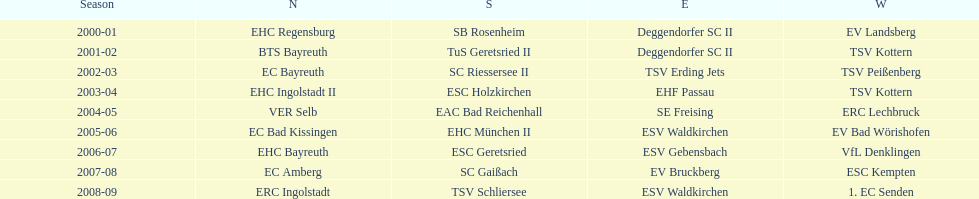Which teams have won in the bavarian ice hockey leagues between 2000 and 2009? EHC Regensburg, SB Rosenheim, Deggendorfer SC II, EV Landsberg, BTS Bayreuth, TuS Geretsried II, TSV Kottern, EC Bayreuth, SC Riessersee II, TSV Erding Jets, TSV Peißenberg, EHC Ingolstadt II, ESC Holzkirchen, EHF Passau, TSV Kottern, VER Selb, EAC Bad Reichenhall, SE Freising, ERC Lechbruck, EC Bad Kissingen, EHC München II, ESV Waldkirchen, EV Bad Wörishofen, EHC Bayreuth, ESC Geretsried, ESV Gebensbach, VfL Denklingen, EC Amberg, SC Gaißach, EV Bruckberg, ESC Kempten, ERC Ingolstadt, TSV Schliersee, ESV Waldkirchen, 1. EC Senden. Which of these winning teams have won the north? EHC Regensburg, BTS Bayreuth, EC Bayreuth, EHC Ingolstadt II, VER Selb, EC Bad Kissingen, EHC Bayreuth, EC Amberg, ERC Ingolstadt. Which of the teams that won the north won in the 2000/2001 season? EHC Regensburg. 